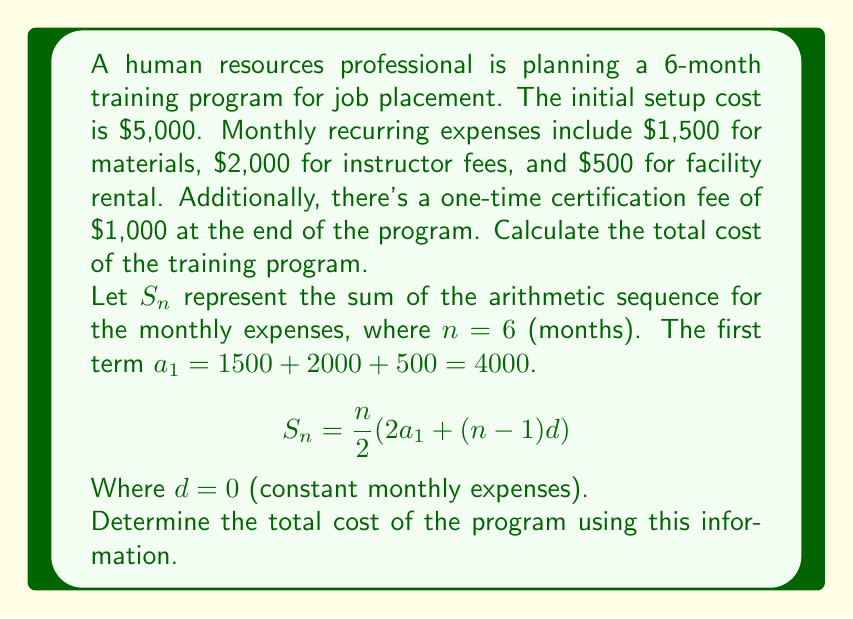Can you solve this math problem? To solve this problem, we'll follow these steps:

1) Calculate the sum of monthly recurring expenses:
   Using the arithmetic sequence formula:
   $$S_6 = \frac{6}{2}(2(4000) + (6-1)0)$$
   $$S_6 = 3(8000 + 0) = 3(8000) = 24000$$

2) Add the initial setup cost:
   $5000 + 24000 = 29000$

3) Add the one-time certification fee:
   $29000 + 1000 = 30000$

Therefore, the total cost of the training program is $30,000.

This calculation considers:
- Initial setup cost: $5,000
- Monthly recurring expenses: $4,000 per month for 6 months
- One-time certification fee: $1,000

The arithmetic sequence formula simplifies the calculation of recurring expenses, which is particularly useful for longer-term programs or when expenses might vary over time.
Answer: $30,000 